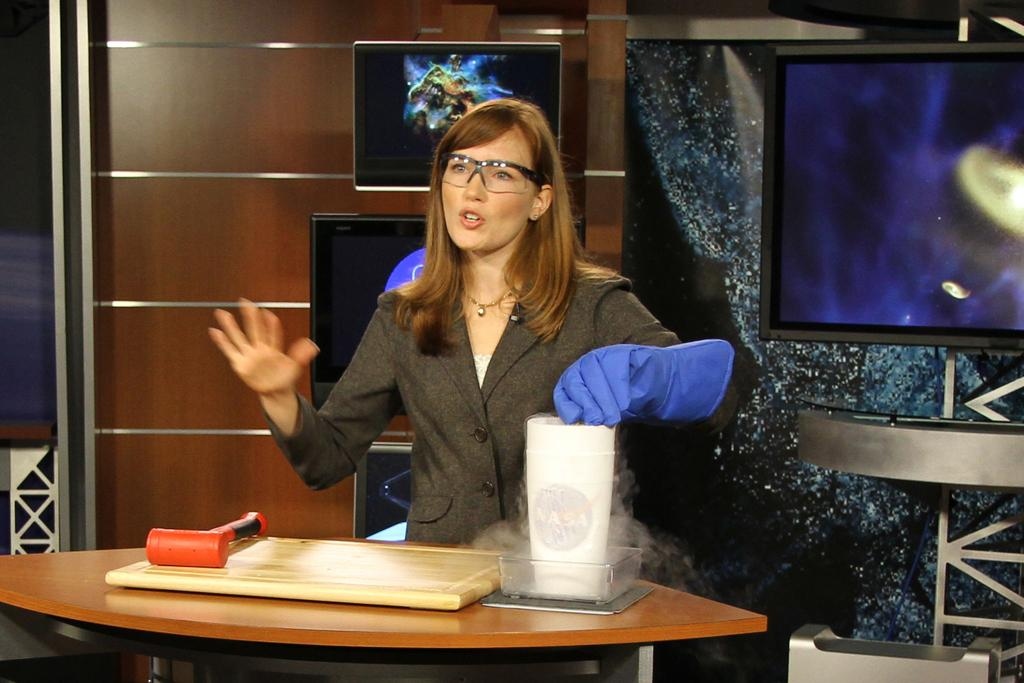Who or what is present in the image? There is a person in the image. Where is the person located in relation to other objects? The person is near a table. What type of surface is visible in the image? There is a wooden board in the image. What is on the table in the image? There is a bowl on the table, and there are objects on the table. What can be seen on the wall in the background? There are screens on the wall in the background. What type of pen is the person using to write on the wooden board in the image? There is no pen visible in the image, and the person is not writing on the wooden board. 